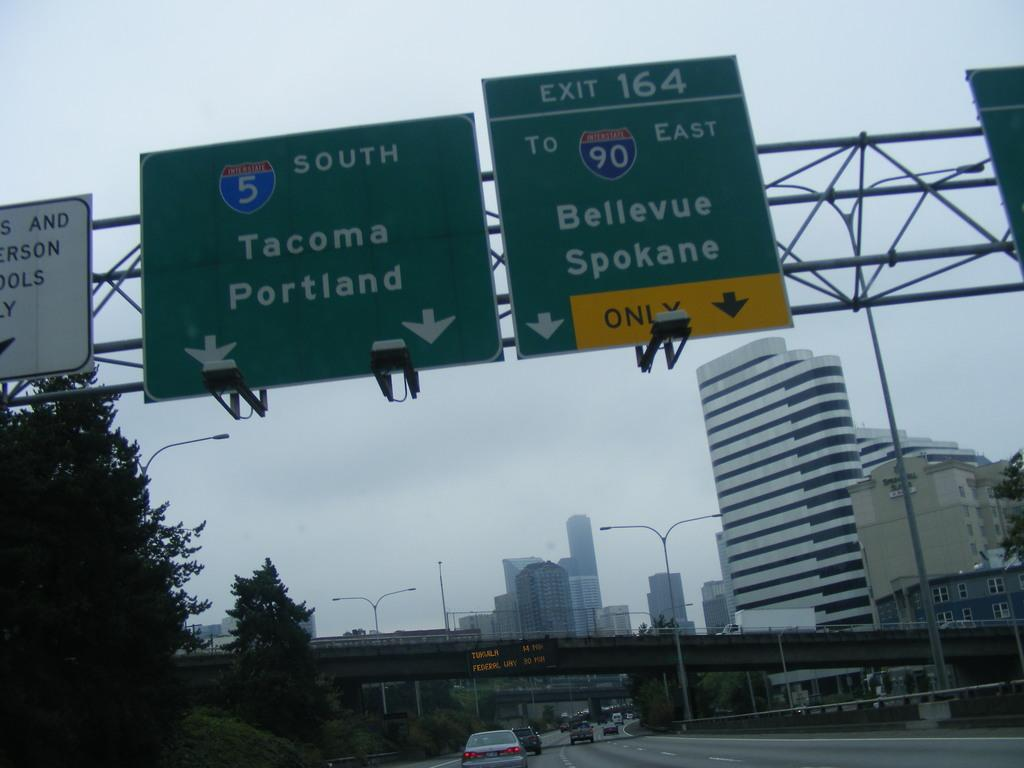<image>
Present a compact description of the photo's key features. Exit 164 leads to the Bellevue Spokane area. 